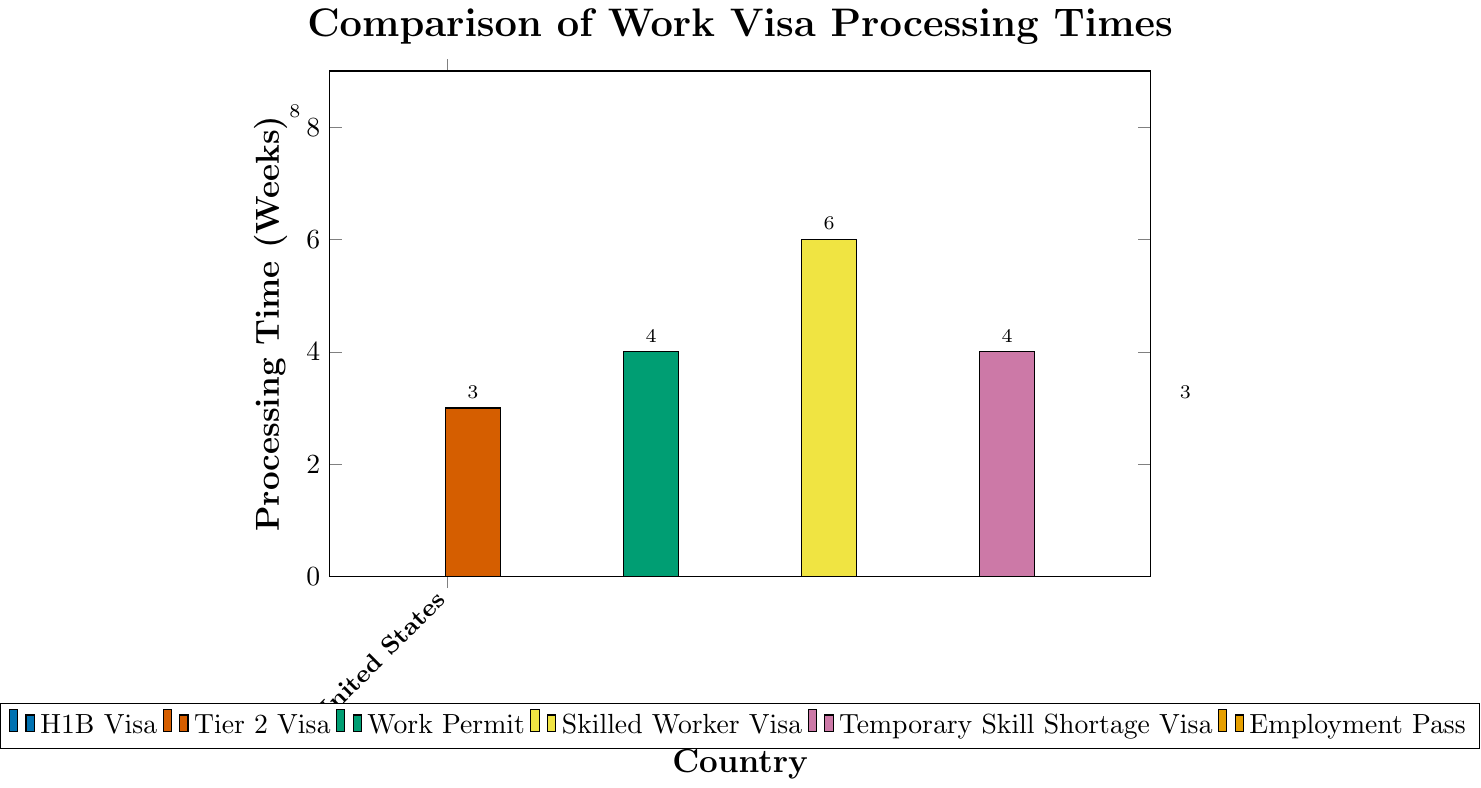Which country has the shortest work visa processing time? From the chart, the shortest processing time is shared by the United Kingdom (Tier 2 Visa) and Singapore (Employment Pass), both at 3 weeks.
Answer: United Kingdom and Singapore What is the average processing time for all the visas shown in the chart? The processing times given are 8 (United States), 3 (United Kingdom), 4 (Germany), 6 (Canada), 4 (Australia), and 3 (Singapore). To find the average, sum them up: 8 + 3 + 4 + 6 + 4 + 3 = 28. Then divide by the number of data points, which is 6: 28 / 6 ≈ 4.67.
Answer: 4.67 weeks Which visa type has the highest processing time, and how long is it? From the chart, the United States (H1B Visa) has the highest processing time of 8 weeks.
Answer: United States (H1B Visa), 8 weeks How much longer does it take to process a H1B Visa in the United States compared to an Employment Pass in Singapore? The processing time for a H1B Visa in the United States is 8 weeks and for an Employment Pass in Singapore is 3 weeks. The difference is 8 - 3 = 5 weeks.
Answer: 5 weeks What is the range of processing times for these work visas? The range is the difference between the maximum and minimum processing times. The maximum is 8 weeks (United States) and the minimum is 3 weeks (United Kingdom and Singapore). The range is 8 - 3 = 5 weeks.
Answer: 5 weeks If you were considering either Australia or Germany for a work visa, which country has a shorter processing time and by how much? The processing time for a Temporary Skill Shortage Visa in Australia is 4 weeks and for a Work Permit in Germany is also 4 weeks. Since they are equal, there is no difference in processing times between the two countries.
Answer: Equal, no difference Which visas have the exact same processing time, and what is that time? From the chart, the Tier 2 Visa in the United Kingdom and the Employment Pass in Singapore both have a processing time of 3 weeks. Additionally, the Work Permit in Germany and the Temporary Skill Shortage Visa in Australia both have a processing time of 4 weeks.
Answer: Tier 2 Visa (UK) and Employment Pass (Singapore) - 3 weeks; Work Permit (Germany) and Temporary Skill Shortage Visa (Australia) - 4 weeks How does the processing time for a Tier 2 Visa in the United Kingdom compare to the Skilled Worker Visa in Canada? The processing time for a Tier 2 Visa in the United Kingdom is 3 weeks, while for a Skilled Worker Visa in Canada it is 6 weeks. The Skilled Worker Visa takes 6 - 3 = 3 weeks longer.
Answer: 3 weeks longer By how much do all visa processing times combined exceed 20 weeks? The total processing time for all visas is 28 weeks. To find how much this exceeds 20 weeks, subtract 20 from 28: 28 - 20 = 8 weeks.
Answer: 8 weeks What is the median processing time of the work visas? The processing times are 3, 3, 4, 4, 6, and 8 weeks. Since there is an even number of data points, the median is the average of the middle two values: (4 + 4) / 2 = 4.
Answer: 4 weeks 